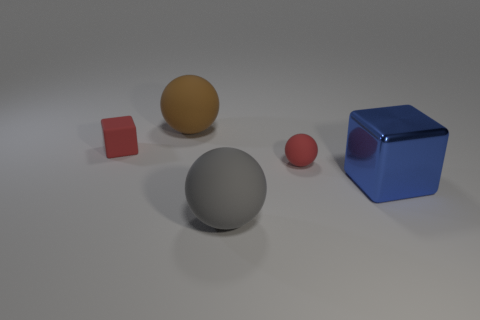What is the material of the sphere that is the same color as the small cube?
Give a very brief answer. Rubber. Are there more matte cubes than large yellow rubber objects?
Your answer should be very brief. Yes. There is a small rubber object on the right side of the large thing that is to the left of the big ball that is in front of the large metallic cube; what color is it?
Provide a succinct answer. Red. Is the material of the big sphere behind the red cube the same as the tiny red block?
Provide a succinct answer. Yes. Is there a small rubber object of the same color as the metal cube?
Your response must be concise. No. Are there any tiny red spheres?
Offer a very short reply. Yes. There is a rubber sphere that is right of the gray rubber ball; does it have the same size as the tiny red matte cube?
Make the answer very short. Yes. Are there fewer big gray objects than red matte things?
Keep it short and to the point. Yes. The big thing in front of the block that is right of the tiny red object that is in front of the red cube is what shape?
Offer a very short reply. Sphere. Is there a brown object made of the same material as the large gray object?
Your answer should be very brief. Yes. 